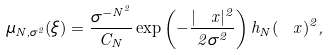<formula> <loc_0><loc_0><loc_500><loc_500>\mu _ { N , \sigma ^ { 2 } } ( \xi ) = \frac { \sigma ^ { - N ^ { 2 } } } { C _ { N } } \exp \left ( - \frac { | \ x | ^ { 2 } } { 2 \sigma ^ { 2 } } \right ) h _ { N } ( \ x ) ^ { 2 } ,</formula> 